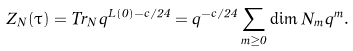<formula> <loc_0><loc_0><loc_500><loc_500>Z _ { N } ( \tau ) = T r _ { N } q ^ { L ( 0 ) - c / 2 4 } = q ^ { - c / 2 4 } \sum _ { m \geq 0 } \dim N _ { m } q ^ { m } .</formula> 